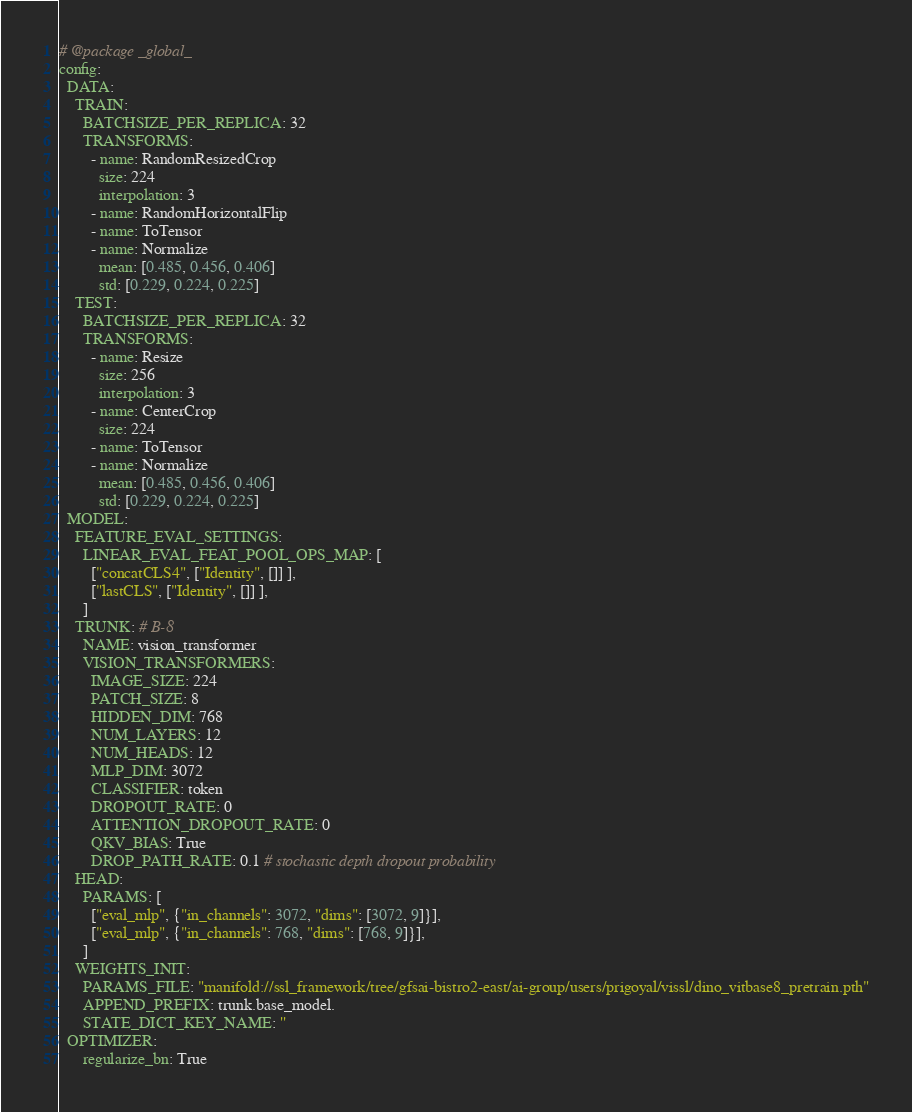<code> <loc_0><loc_0><loc_500><loc_500><_YAML_># @package _global_
config:
  DATA:
    TRAIN:
      BATCHSIZE_PER_REPLICA: 32
      TRANSFORMS:
        - name: RandomResizedCrop
          size: 224
          interpolation: 3
        - name: RandomHorizontalFlip
        - name: ToTensor
        - name: Normalize
          mean: [0.485, 0.456, 0.406]
          std: [0.229, 0.224, 0.225]
    TEST:
      BATCHSIZE_PER_REPLICA: 32
      TRANSFORMS:
        - name: Resize
          size: 256
          interpolation: 3
        - name: CenterCrop
          size: 224
        - name: ToTensor
        - name: Normalize
          mean: [0.485, 0.456, 0.406]
          std: [0.229, 0.224, 0.225]
  MODEL:
    FEATURE_EVAL_SETTINGS:
      LINEAR_EVAL_FEAT_POOL_OPS_MAP: [
        ["concatCLS4", ["Identity", []] ],
        ["lastCLS", ["Identity", []] ],
      ]
    TRUNK: # B-8
      NAME: vision_transformer
      VISION_TRANSFORMERS:
        IMAGE_SIZE: 224
        PATCH_SIZE: 8
        HIDDEN_DIM: 768
        NUM_LAYERS: 12
        NUM_HEADS: 12
        MLP_DIM: 3072
        CLASSIFIER: token
        DROPOUT_RATE: 0
        ATTENTION_DROPOUT_RATE: 0
        QKV_BIAS: True
        DROP_PATH_RATE: 0.1 # stochastic depth dropout probability
    HEAD:
      PARAMS: [
        ["eval_mlp", {"in_channels": 3072, "dims": [3072, 9]}],
        ["eval_mlp", {"in_channels": 768, "dims": [768, 9]}],
      ]
    WEIGHTS_INIT:
      PARAMS_FILE: "manifold://ssl_framework/tree/gfsai-bistro2-east/ai-group/users/prigoyal/vissl/dino_vitbase8_pretrain.pth"
      APPEND_PREFIX: trunk.base_model.
      STATE_DICT_KEY_NAME: ''
  OPTIMIZER:
      regularize_bn: True
</code> 